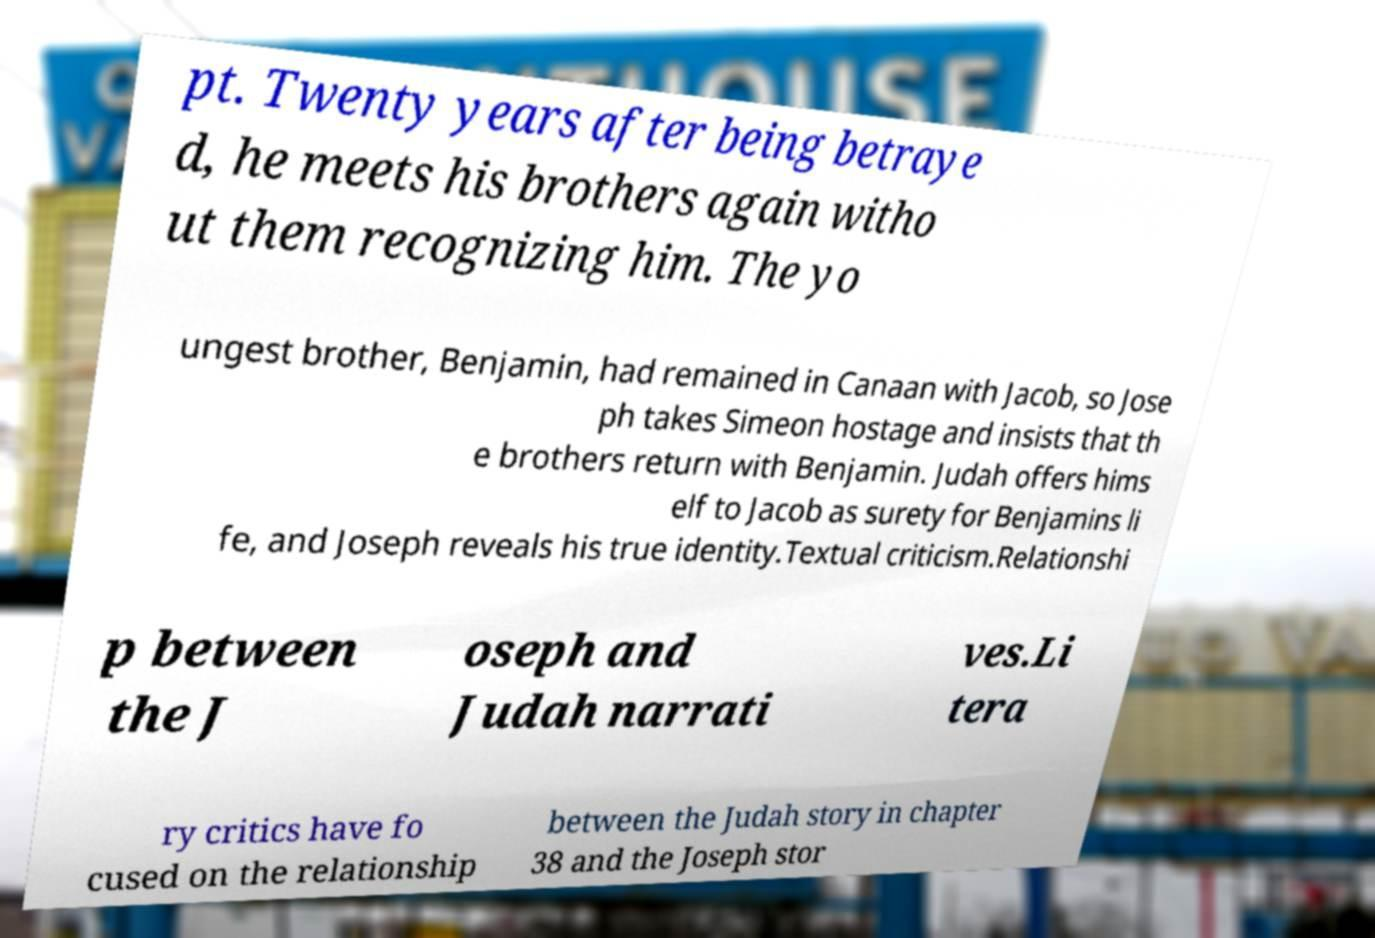Can you accurately transcribe the text from the provided image for me? pt. Twenty years after being betraye d, he meets his brothers again witho ut them recognizing him. The yo ungest brother, Benjamin, had remained in Canaan with Jacob, so Jose ph takes Simeon hostage and insists that th e brothers return with Benjamin. Judah offers hims elf to Jacob as surety for Benjamins li fe, and Joseph reveals his true identity.Textual criticism.Relationshi p between the J oseph and Judah narrati ves.Li tera ry critics have fo cused on the relationship between the Judah story in chapter 38 and the Joseph stor 